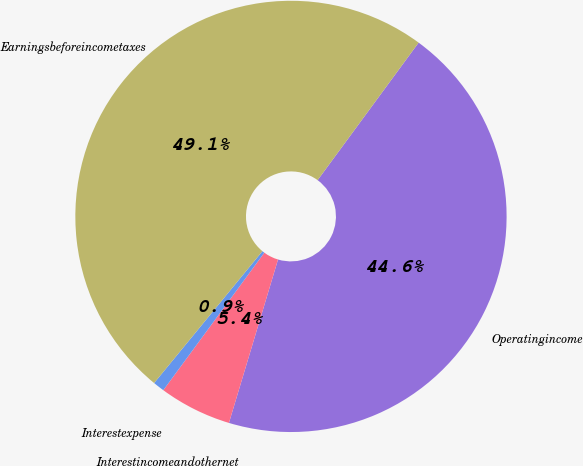Convert chart to OTSL. <chart><loc_0><loc_0><loc_500><loc_500><pie_chart><fcel>Operatingincome<fcel>Interestincomeandothernet<fcel>Interestexpense<fcel>Earningsbeforeincometaxes<nl><fcel>44.56%<fcel>5.44%<fcel>0.86%<fcel>49.14%<nl></chart> 